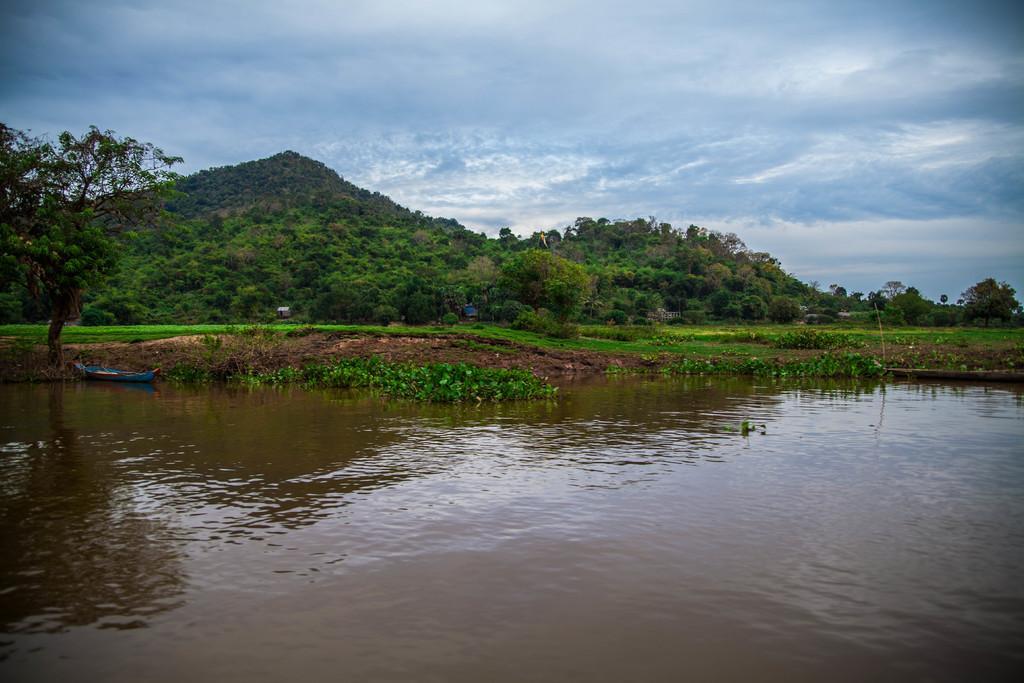Could you give a brief overview of what you see in this image? There is a river and a small boat beside the river and in front of the boat there is a lot of grass and many trees and behind the trees there is a big mountain. 